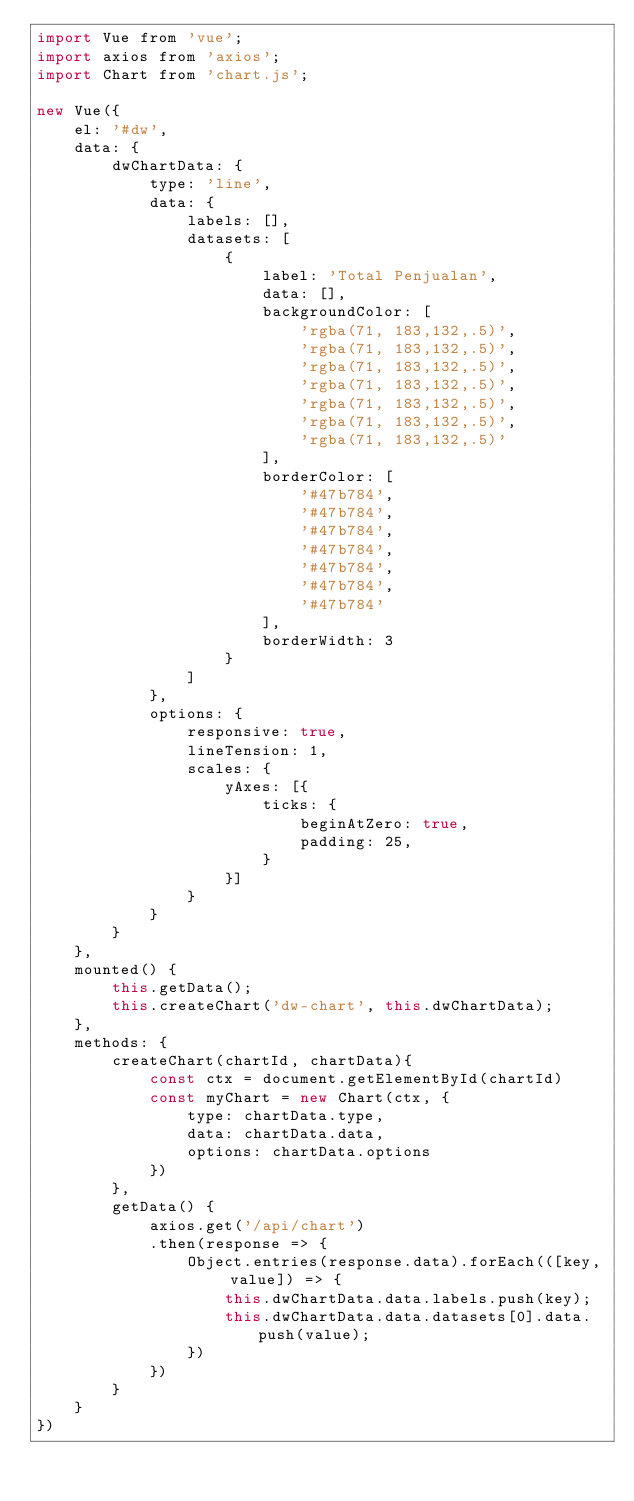<code> <loc_0><loc_0><loc_500><loc_500><_JavaScript_>import Vue from 'vue';
import axios from 'axios';
import Chart from 'chart.js';

new Vue({
	el: '#dw',
	data: {
		dwChartData: {
			type: 'line',
			data: {
				labels: [],
				datasets: [
					{
						label: 'Total Penjualan',
						data: [],
						backgroundColor: [
							'rgba(71, 183,132,.5)',
                            'rgba(71, 183,132,.5)',
                            'rgba(71, 183,132,.5)',
                            'rgba(71, 183,132,.5)',
                            'rgba(71, 183,132,.5)',
                            'rgba(71, 183,132,.5)',
                            'rgba(71, 183,132,.5)'
						],
						borderColor: [
                            '#47b784',
                            '#47b784',
                            '#47b784',
                            '#47b784',
                            '#47b784',
                            '#47b784',
                            '#47b784'
                        ],
                        borderWidth: 3
					}
				]
			},
			options: {
				responsive: true,
                lineTension: 1,
                scales: {
                    yAxes: [{
                        ticks: {
                            beginAtZero: true,
                            padding: 25,
                        }
                    }]
                }
			}
		}
	},
	mounted() {
		this.getData();
		this.createChart('dw-chart', this.dwChartData);
	},
	methods: {
		createChart(chartId, chartData){
			const ctx = document.getElementById(chartId)
			const myChart = new Chart(ctx, {
				type: chartData.type,
				data: chartData.data,
				options: chartData.options
			})
		},
		getData() {
			axios.get('/api/chart')
			.then(response => {
				Object.entries(response.data).forEach(([key, value]) => {
					this.dwChartData.data.labels.push(key);
					this.dwChartData.data.datasets[0].data.push(value);
				})
			})
		}
	}
})</code> 